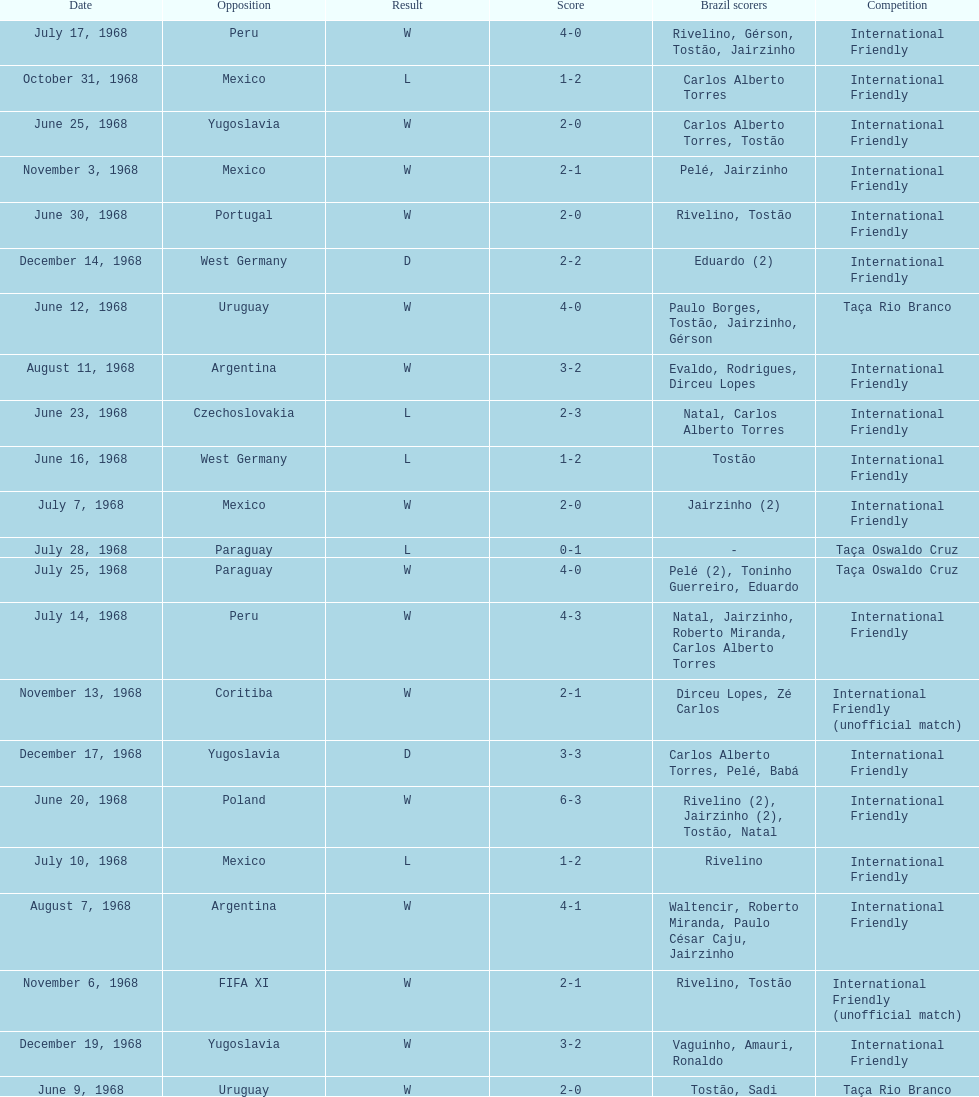Overall amount of triumphs 15. 